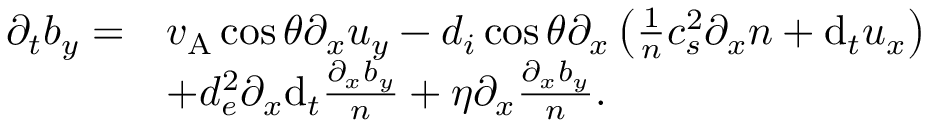<formula> <loc_0><loc_0><loc_500><loc_500>\begin{array} { r l } { \partial _ { t } b _ { y } = } & { v _ { A } \cos \theta \partial _ { x } u _ { y } - d _ { i } \cos \theta \partial _ { x } \left ( \frac { 1 } { n } c _ { s } ^ { 2 } \partial _ { x } n + d _ { t } u _ { x } \right ) } \\ & { + d _ { e } ^ { 2 } \partial _ { x } d _ { t } \frac { \partial _ { x } b _ { y } } { n } + \eta \partial _ { x } \frac { \partial _ { x } b _ { y } } { n } . } \end{array}</formula> 